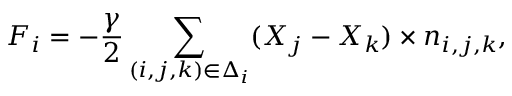<formula> <loc_0><loc_0><loc_500><loc_500>\boldsymbol F _ { i } = - \frac { \gamma } { 2 } \sum _ { ( i , j , k ) \in \Delta _ { i } } ( \boldsymbol X _ { j } - \boldsymbol X _ { k } ) \times \boldsymbol n _ { i , j , k } ,</formula> 